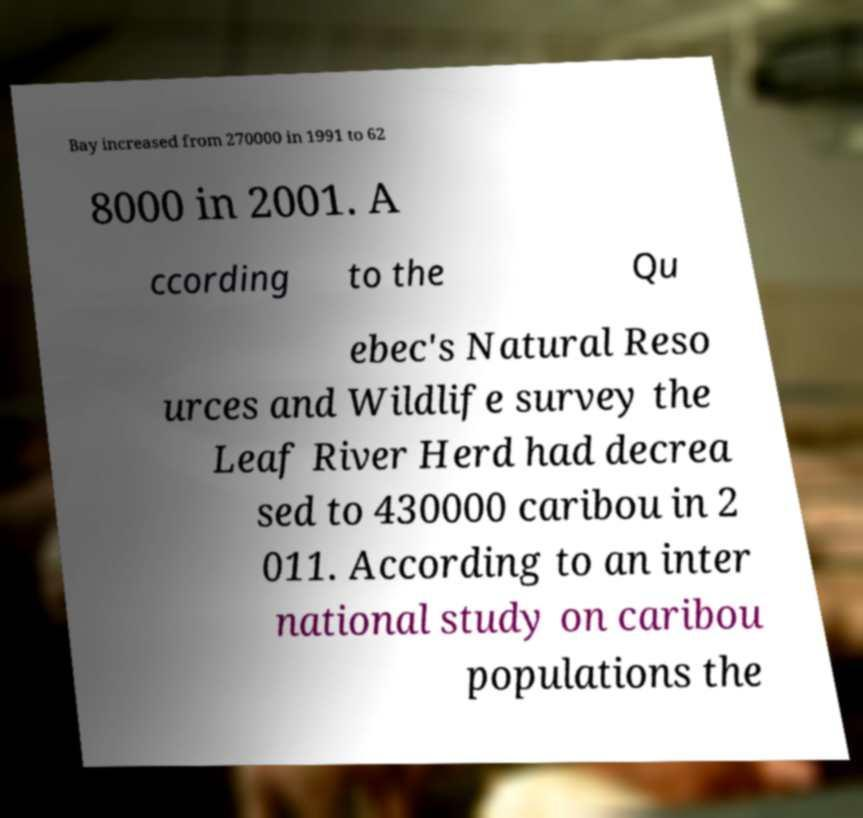Please identify and transcribe the text found in this image. Bay increased from 270000 in 1991 to 62 8000 in 2001. A ccording to the Qu ebec's Natural Reso urces and Wildlife survey the Leaf River Herd had decrea sed to 430000 caribou in 2 011. According to an inter national study on caribou populations the 